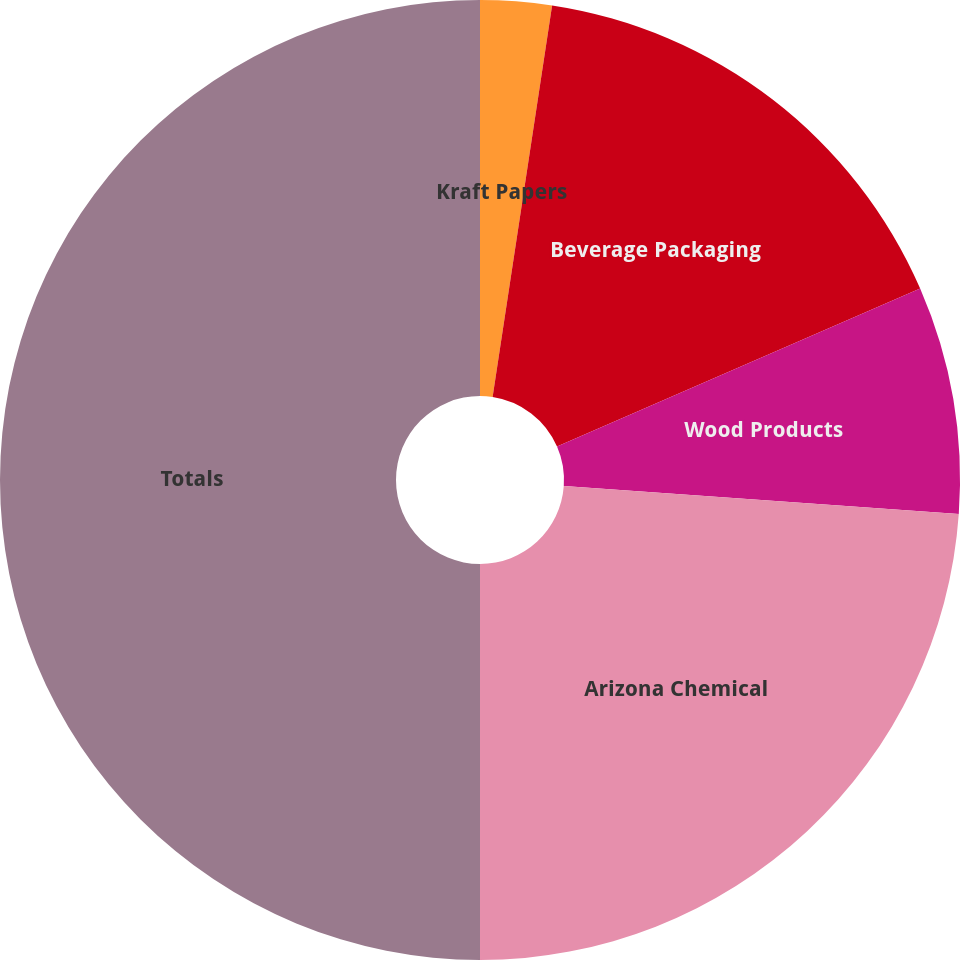Convert chart to OTSL. <chart><loc_0><loc_0><loc_500><loc_500><pie_chart><fcel>Kraft Papers<fcel>Beverage Packaging<fcel>Wood Products<fcel>Arizona Chemical<fcel>Totals<nl><fcel>2.4%<fcel>16.07%<fcel>7.66%<fcel>23.87%<fcel>50.0%<nl></chart> 